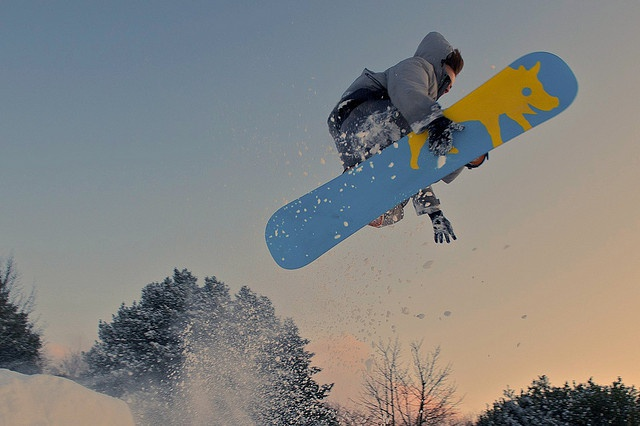Describe the objects in this image and their specific colors. I can see snowboard in gray, olive, and blue tones and people in gray and black tones in this image. 